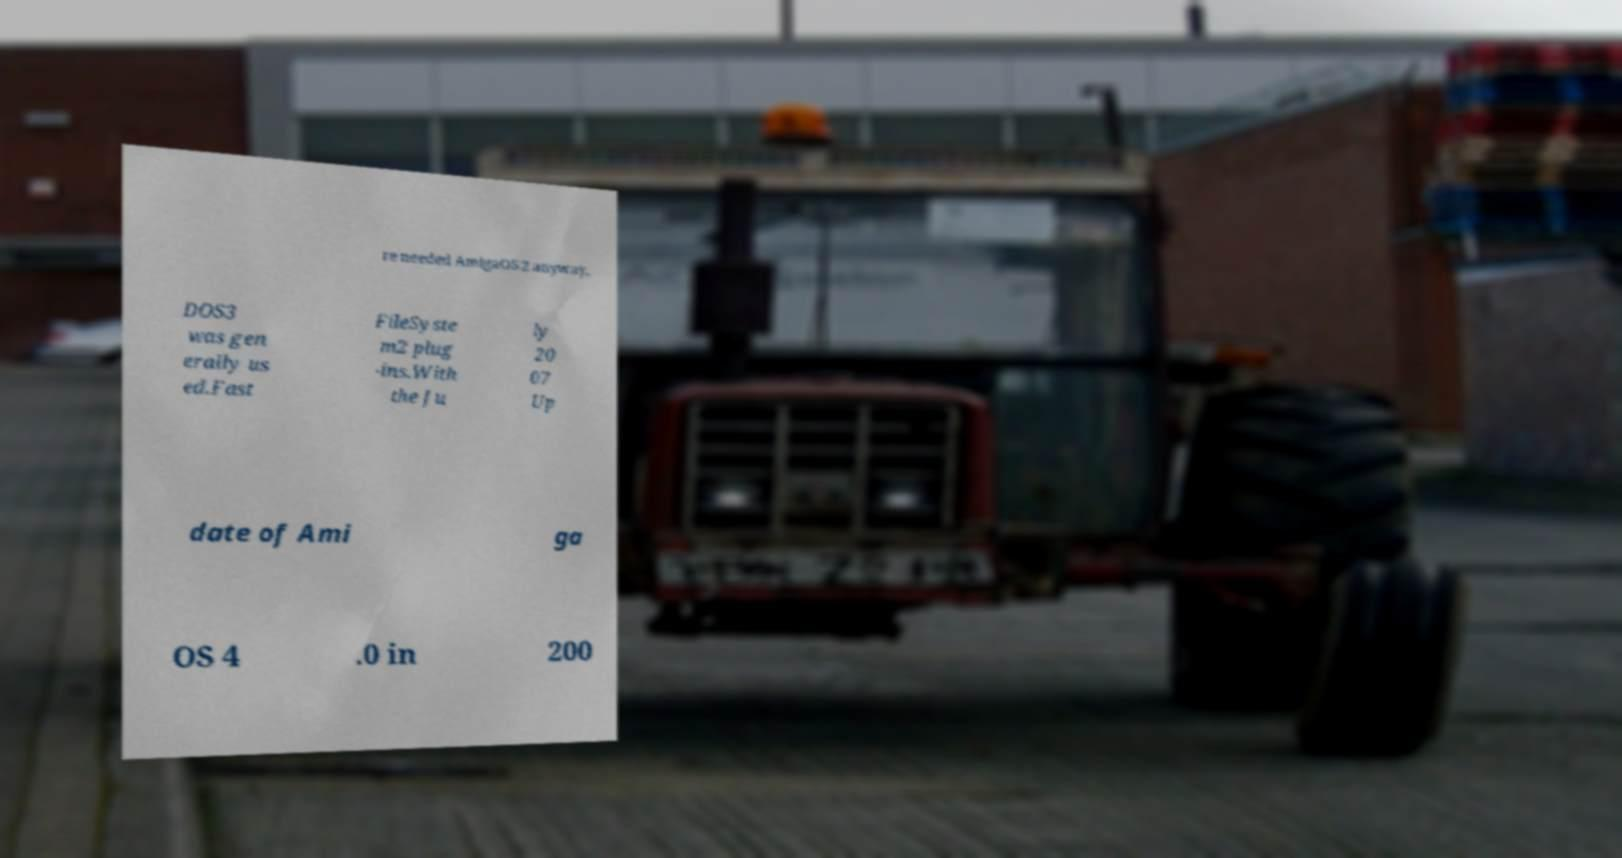Can you accurately transcribe the text from the provided image for me? re needed AmigaOS 2 anyway, DOS3 was gen erally us ed.Fast FileSyste m2 plug -ins.With the Ju ly 20 07 Up date of Ami ga OS 4 .0 in 200 